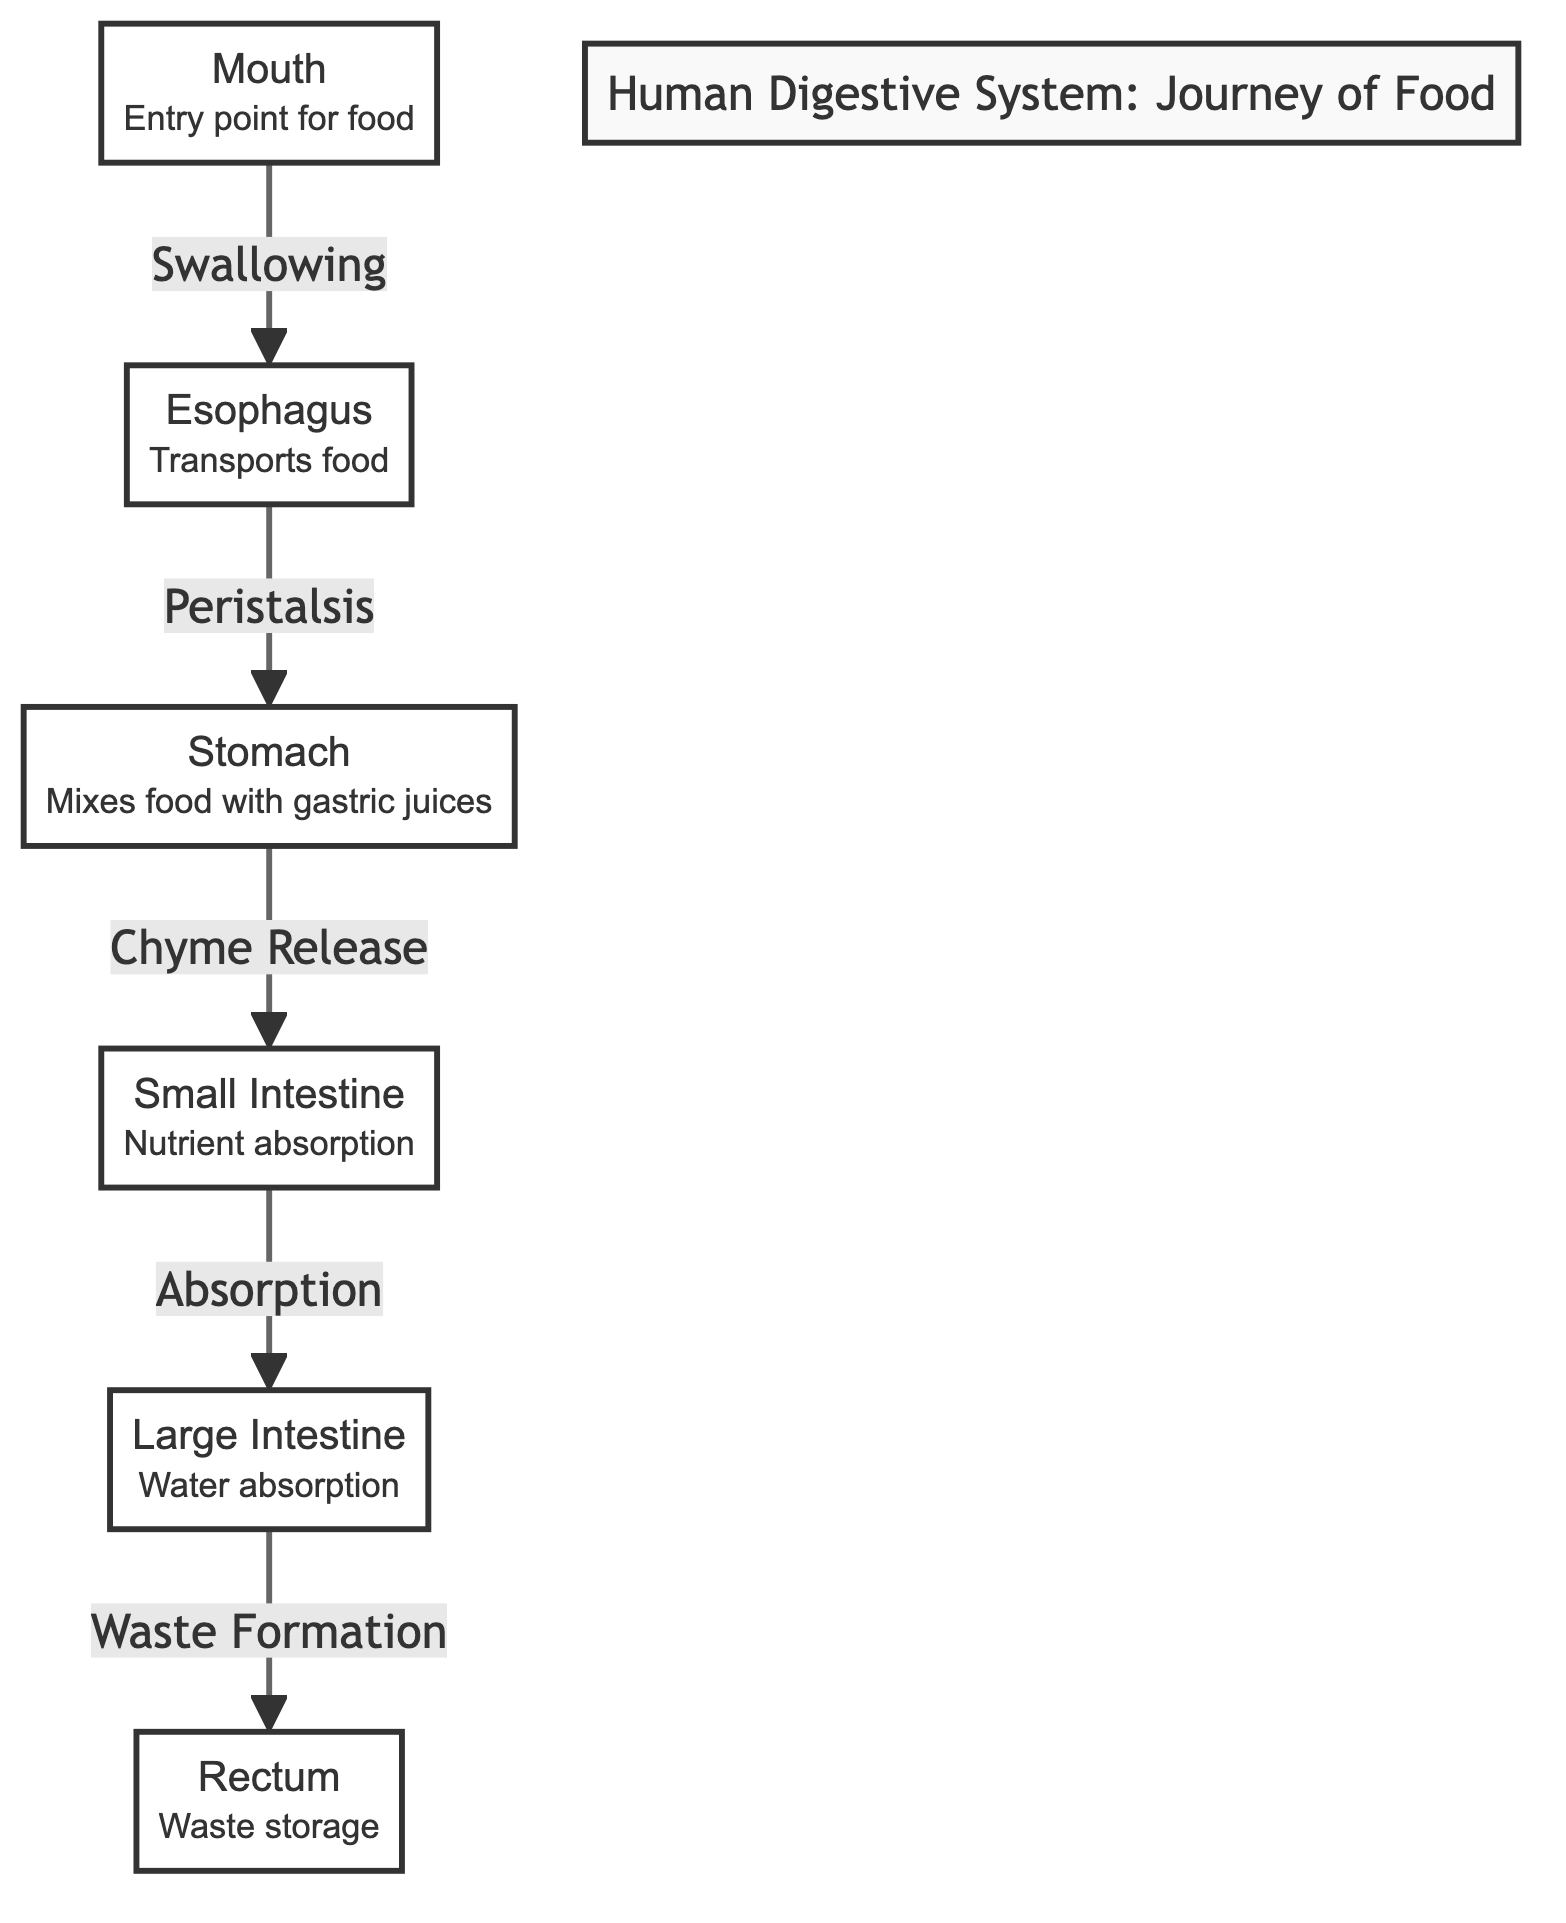What organ is the entry point for food? The diagram labels the mouth as the entry point for food, indicating the starting point of the digestive process.
Answer: Mouth How many organs are shown in the diagram? By counting each labeled organ in the diagram, I see there are a total of six distinct organs listed.
Answer: 6 What process occurs in the esophagus? The diagram specifies that the esophagus is responsible for transporting food, indicating its primary function in the digestive system.
Answer: Transports food Which organ is responsible for mixing food with gastric juices? The diagram identifies the stomach as the organ that mixes food with gastric juices, highlighting its role in digestion.
Answer: Stomach What is formed in the large intestine? The diagram indicates that the large intestine is responsible for waste formation, clarifying its function in the latter part of digestion.
Answer: Waste Formation What is the sequence of food flow starting from the mouth? Observing the flowchart from the mouth, food travels through the esophagus to the stomach, then to the small intestine, followed by the large intestine, and finally to the rectum, illustrating the complete pathway.
Answer: Mouth → Esophagus → Stomach → Small Intestine → Large Intestine → Rectum What type of absorption occurs in the small intestine? According to the diagram, the small intestine is where nutrient absorption takes place, emphasizing its crucial role in extracting nutrients from food.
Answer: Nutrient absorption Which organ is indicated for waste storage? The diagram states that the rectum serves as the waste storage organ, pointing to its function in the digestive system.
Answer: Rectum What color represents the stomach in the diagram? The diagram uses a specific color code, where the stomach is colored in a shade of red-toned (#ff6f61), visually distinguishing it from other organs.
Answer: Red What movement is described entering the stomach? The diagram specifies that chyme release is the movement described when food enters the stomach, illustrating the action happening at this stage.
Answer: Chyme Release 